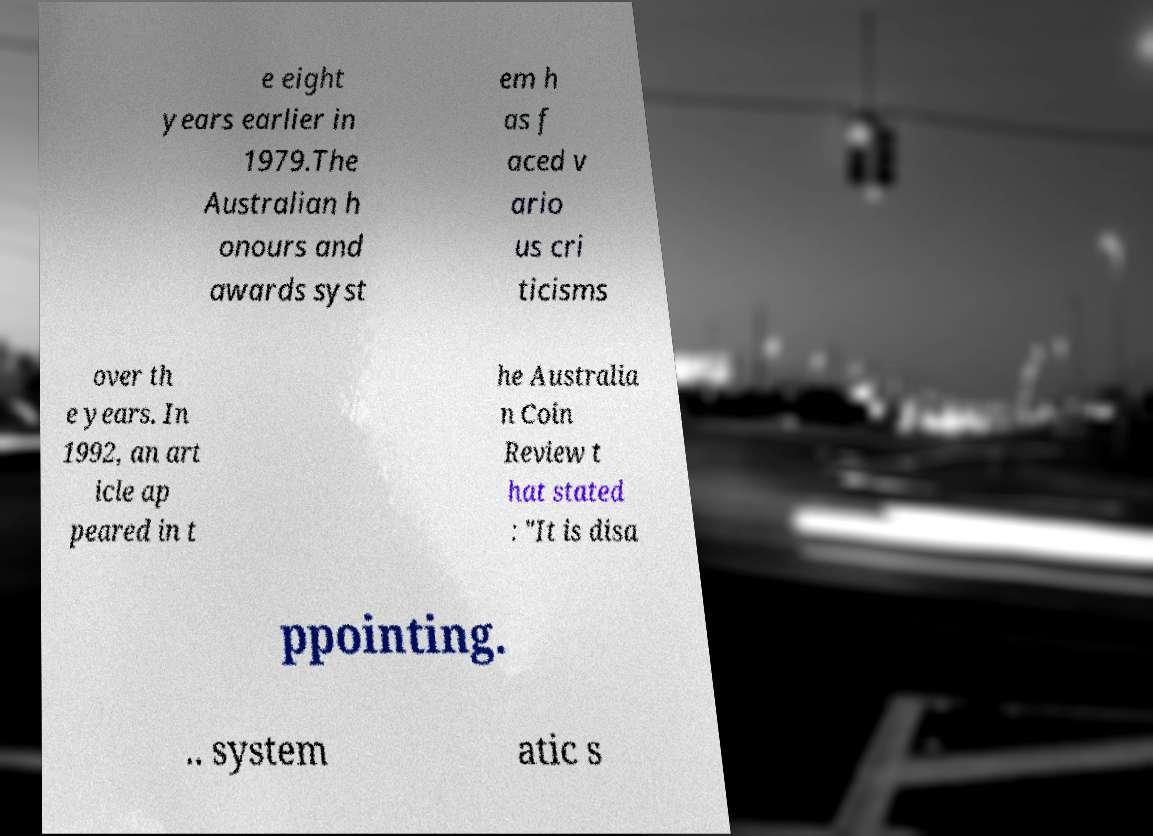There's text embedded in this image that I need extracted. Can you transcribe it verbatim? e eight years earlier in 1979.The Australian h onours and awards syst em h as f aced v ario us cri ticisms over th e years. In 1992, an art icle ap peared in t he Australia n Coin Review t hat stated : "It is disa ppointing. .. system atic s 